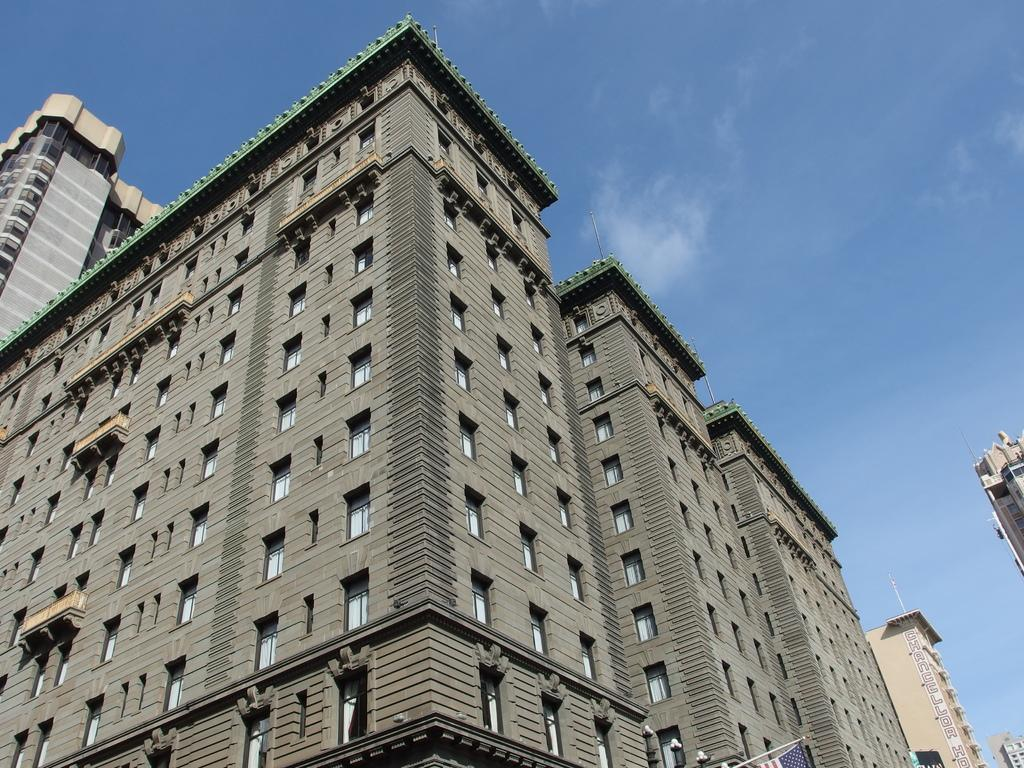What structures are present in the image? There are buildings in the image. What can be seen in the background of the image? The sky is visible in the background of the image. Where is the throne located in the image? There is no throne present in the image. What type of joke can be seen in the image? There is no joke present in the image. 